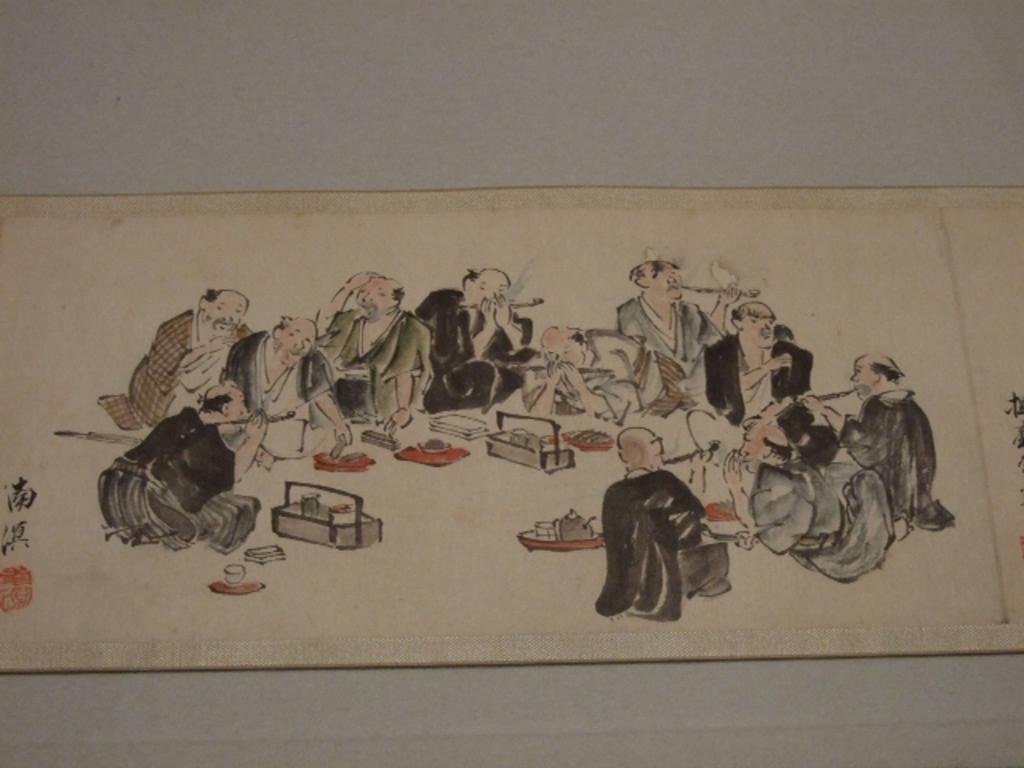What is the main subject of the sketch in the image? The main subject of the sketch in the image is people. Are there any other elements in the sketch besides the people? Yes, there are other objects in the sketch. What is the color of the surface on which the sketch is drawn? The sketch is on a white color surface. Can you tell me how many kettles are visible in the sketch? There is no kettle present in the sketch; it only contains a sketch of people and other objects. What type of donkey is depicted in the sketch? There is no donkey present in the sketch; it only contains a sketch of people and other objects. 